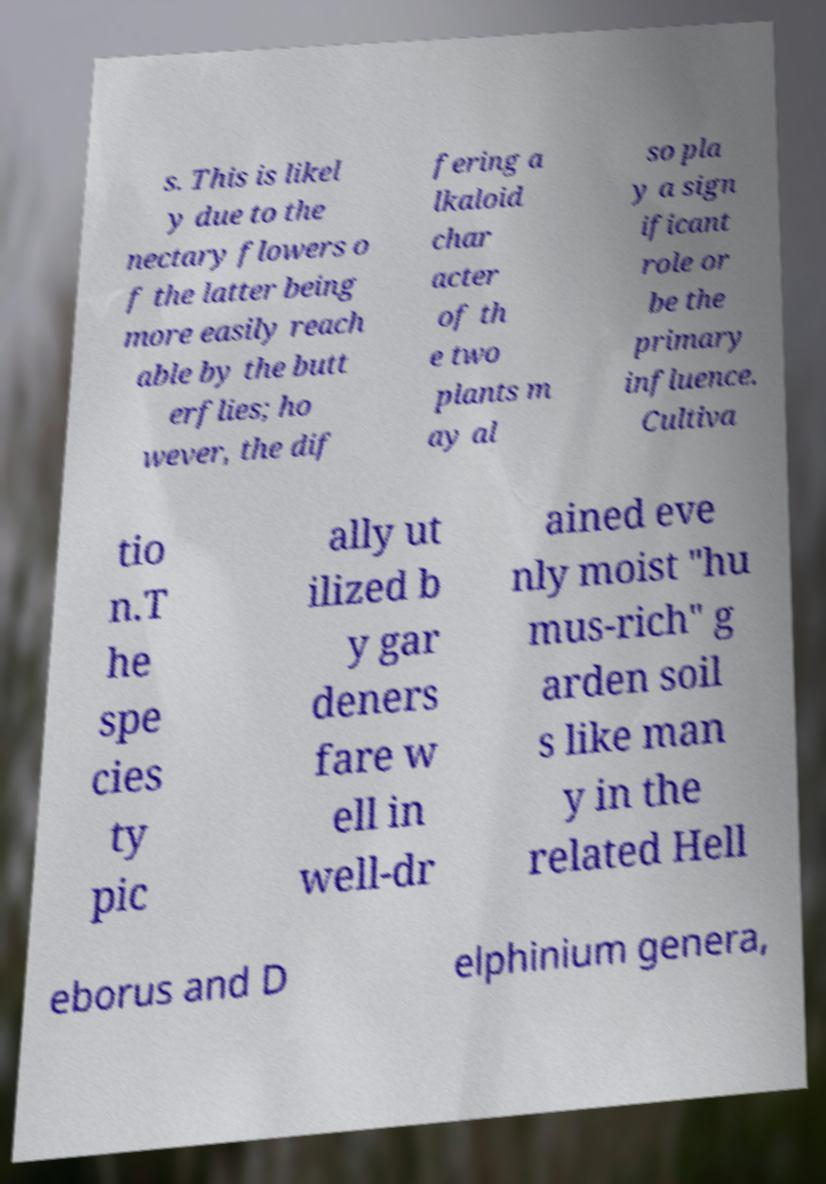Can you read and provide the text displayed in the image?This photo seems to have some interesting text. Can you extract and type it out for me? s. This is likel y due to the nectary flowers o f the latter being more easily reach able by the butt erflies; ho wever, the dif fering a lkaloid char acter of th e two plants m ay al so pla y a sign ificant role or be the primary influence. Cultiva tio n.T he spe cies ty pic ally ut ilized b y gar deners fare w ell in well-dr ained eve nly moist "hu mus-rich" g arden soil s like man y in the related Hell eborus and D elphinium genera, 